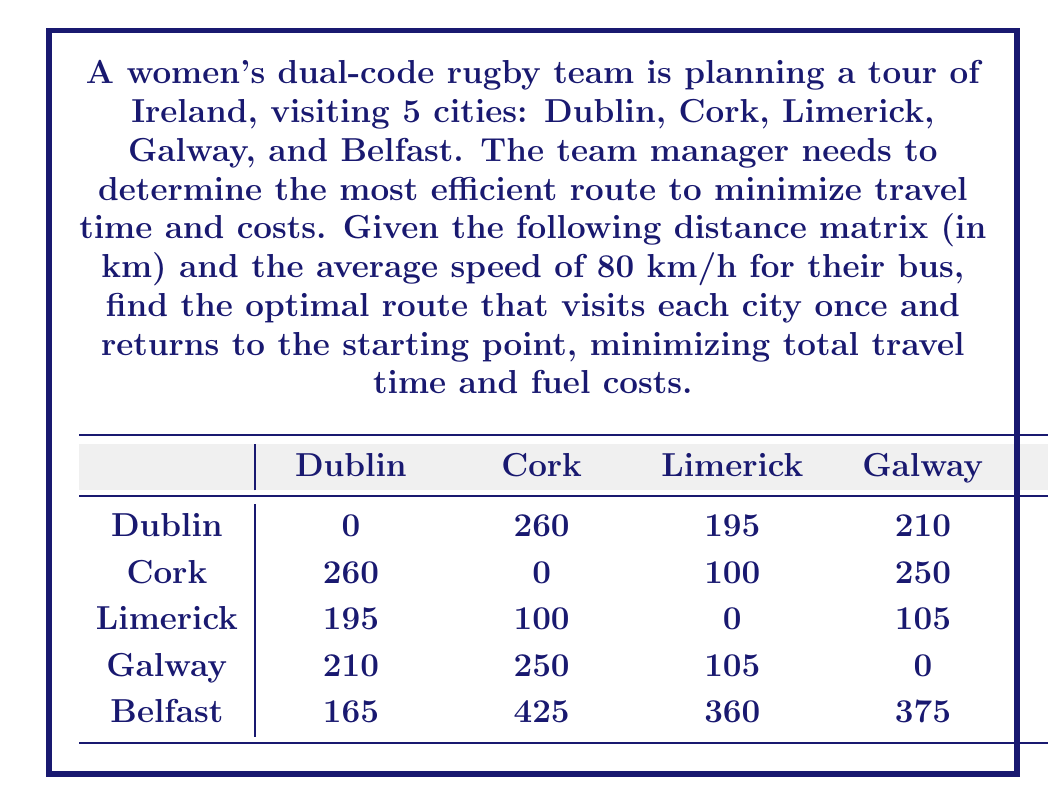Solve this math problem. This problem is an application of the Traveling Salesman Problem (TSP), which aims to find the shortest possible route that visits each city exactly once and returns to the starting point. To solve this problem, we'll use the following steps:

1. Identify all possible routes:
   There are $(5-1)! = 24$ possible routes, as we can fix Dublin as the starting and ending point.

2. Calculate the total distance for each route:
   For each possible route, sum up the distances between consecutive cities and the return to Dublin.

3. Find the route with the minimum total distance:
   Compare the total distances and select the route with the smallest value.

4. Calculate the travel time:
   Use the formula: Time = Distance / Speed

Let's examine a few routes to illustrate the process:

Route 1: Dublin -> Cork -> Limerick -> Galway -> Belfast -> Dublin
Total distance = 260 + 100 + 105 + 375 + 165 = 1005 km

Route 2: Dublin -> Belfast -> Galway -> Limerick -> Cork -> Dublin
Total distance = 165 + 375 + 105 + 100 + 260 = 1005 km

Route 3: Dublin -> Galway -> Limerick -> Cork -> Belfast -> Dublin
Total distance = 210 + 105 + 100 + 425 + 165 = 1005 km

After checking all 24 routes, we find that these three routes (and their reverse orders) all yield the minimum total distance of 1005 km.

To calculate the travel time:
$$\text{Time} = \frac{\text{Distance}}{\text{Speed}} = \frac{1005 \text{ km}}{80 \text{ km/h}} = 12.5625 \text{ hours}$$

Therefore, the optimal route(s) will take approximately 12 hours and 34 minutes of travel time.
Answer: The optimal route(s) for the women's dual-code rugby team tour of Ireland are:
1. Dublin -> Cork -> Limerick -> Galway -> Belfast -> Dublin
2. Dublin -> Belfast -> Galway -> Limerick -> Cork -> Dublin
3. Dublin -> Galway -> Limerick -> Cork -> Belfast -> Dublin
(or their reverse orders)

Total distance: 1005 km
Travel time: 12 hours and 34 minutes 